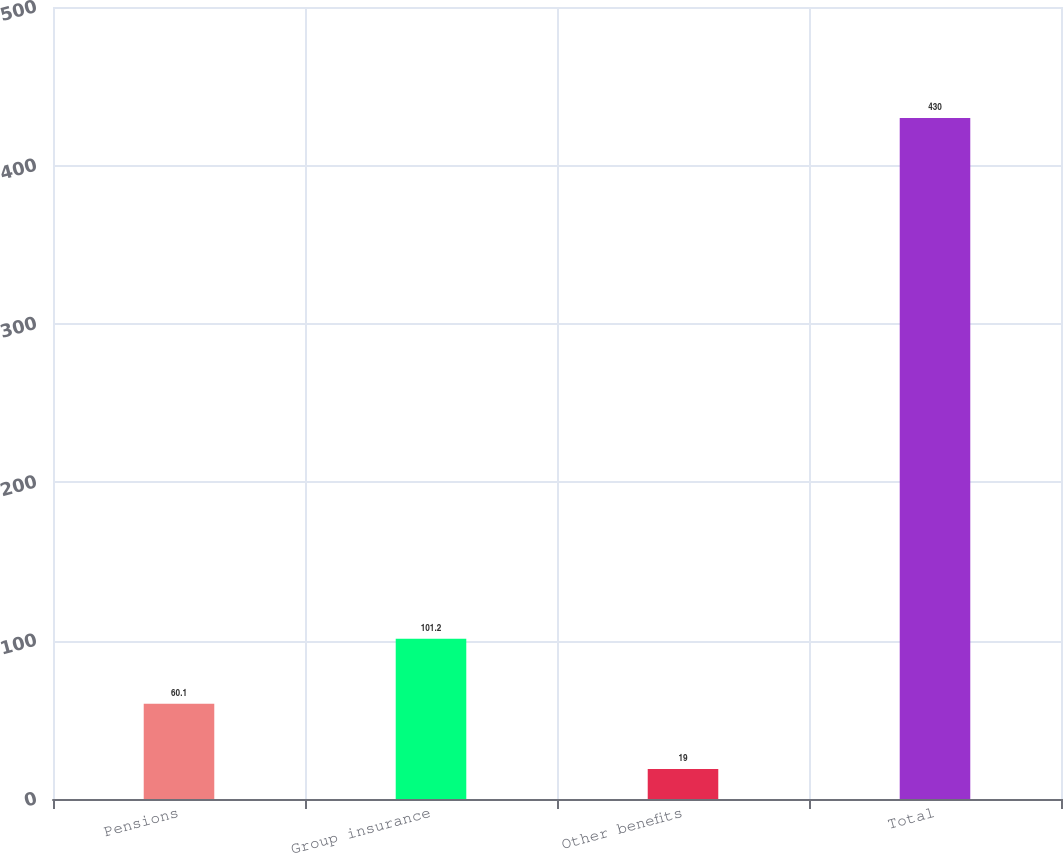Convert chart. <chart><loc_0><loc_0><loc_500><loc_500><bar_chart><fcel>Pensions<fcel>Group insurance<fcel>Other benefits<fcel>Total<nl><fcel>60.1<fcel>101.2<fcel>19<fcel>430<nl></chart> 